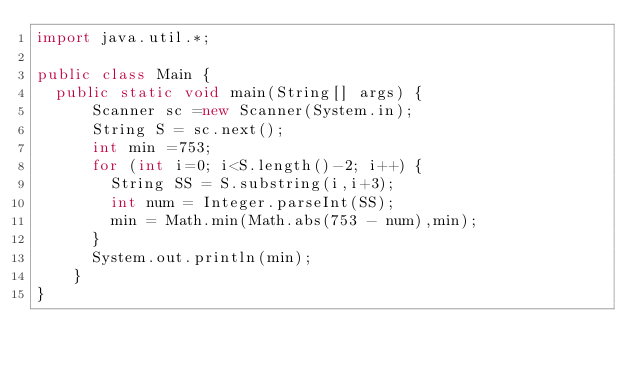Convert code to text. <code><loc_0><loc_0><loc_500><loc_500><_Java_>import java.util.*;

public class Main {
	public static void main(String[] args) {
      Scanner sc =new Scanner(System.in);
      String S = sc.next();
      int min =753;
      for (int i=0; i<S.length()-2; i++) {
        String SS = S.substring(i,i+3);
        int num = Integer.parseInt(SS);
        min = Math.min(Math.abs(753 - num),min);
      }
      System.out.println(min);
    }
}</code> 